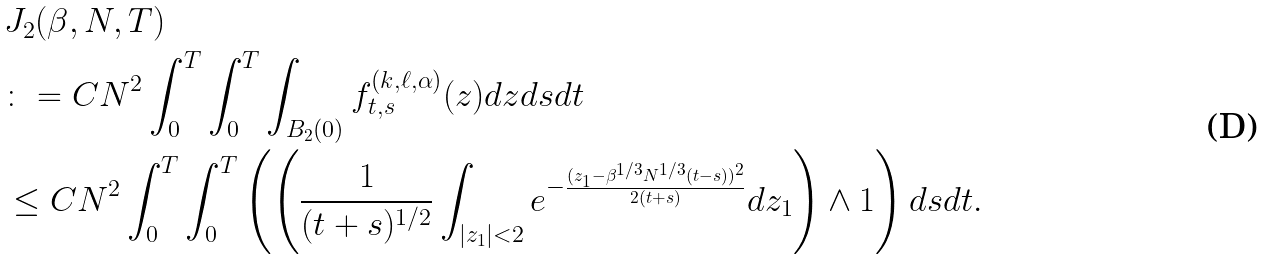Convert formula to latex. <formula><loc_0><loc_0><loc_500><loc_500>& J _ { 2 } ( \beta , N , T ) \\ & \colon = C N ^ { 2 } \int _ { 0 } ^ { T } \int _ { 0 } ^ { T } \int _ { B _ { 2 } ( 0 ) } f ^ { ( k , \ell , \alpha ) } _ { t , s } ( z ) d z d s d t \\ & \leq C N ^ { 2 } \int _ { 0 } ^ { T } \int _ { 0 } ^ { T } \left ( \left ( \frac { 1 } { ( t + s ) ^ { 1 / 2 } } \int _ { | z _ { 1 } | < 2 } e ^ { - \frac { ( z _ { 1 } - \beta ^ { 1 / 3 } N ^ { 1 / 3 } ( t - s ) ) ^ { 2 } } { 2 ( t + s ) } } d z _ { 1 } \right ) \wedge 1 \right ) d s d t .</formula> 